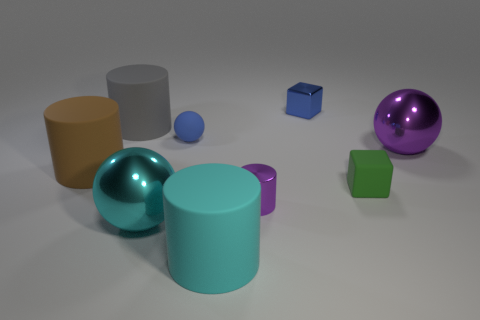Can you comment on the composition of this image and what effect it has on the viewer? The composition of the image is balanced yet dynamic, with a variety of geometric shapes scattered throughout. The mixture of cylinders, spheres, and cubes in different colors and sizes draws the viewer's eye across the picture. The relatively uniform background helps the objects to stand out, and the varying sizes create a sense of depth and perspective. 